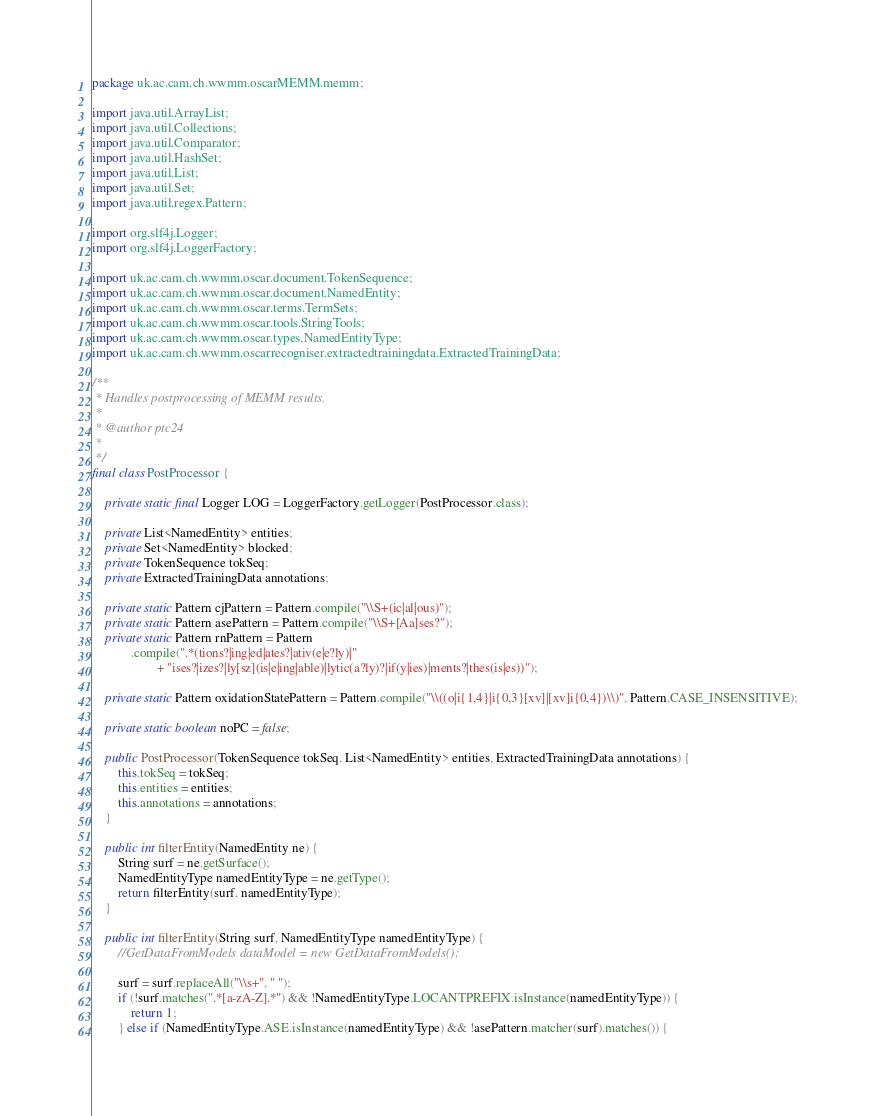<code> <loc_0><loc_0><loc_500><loc_500><_Java_>package uk.ac.cam.ch.wwmm.oscarMEMM.memm;

import java.util.ArrayList;
import java.util.Collections;
import java.util.Comparator;
import java.util.HashSet;
import java.util.List;
import java.util.Set;
import java.util.regex.Pattern;

import org.slf4j.Logger;
import org.slf4j.LoggerFactory;

import uk.ac.cam.ch.wwmm.oscar.document.TokenSequence;
import uk.ac.cam.ch.wwmm.oscar.document.NamedEntity;
import uk.ac.cam.ch.wwmm.oscar.terms.TermSets;
import uk.ac.cam.ch.wwmm.oscar.tools.StringTools;
import uk.ac.cam.ch.wwmm.oscar.types.NamedEntityType;
import uk.ac.cam.ch.wwmm.oscarrecogniser.extractedtrainingdata.ExtractedTrainingData;

/**
 * Handles postprocessing of MEMM results.
 * 
 * @author ptc24
 * 
 */
final class PostProcessor {

	private static final Logger LOG = LoggerFactory.getLogger(PostProcessor.class);
	
	private List<NamedEntity> entities;
	private Set<NamedEntity> blocked;
	private TokenSequence tokSeq;
	private ExtractedTrainingData annotations;

	private static Pattern cjPattern = Pattern.compile("\\S+(ic|al|ous)");
	private static Pattern asePattern = Pattern.compile("\\S+[Aa]ses?");
	private static Pattern rnPattern = Pattern
			.compile(".*(tions?|ing|ed|ates?|ativ(e|e?ly)|"
					+ "ises?|izes?|ly[sz](is|e|ing|able)|lytic(a?ly)?|if(y|ies)|ments?|thes(is|es))");

    private static Pattern oxidationStatePattern = Pattern.compile("\\((o|i{1,4}|i{0,3}[xv]|[xv]i{0,4})\\)", Pattern.CASE_INSENSITIVE);

	private static boolean noPC = false;

	public PostProcessor(TokenSequence tokSeq, List<NamedEntity> entities, ExtractedTrainingData annotations) {
		this.tokSeq = tokSeq;
		this.entities = entities;
		this.annotations = annotations;
	}

	public int filterEntity(NamedEntity ne) {
		String surf = ne.getSurface();
		NamedEntityType namedEntityType = ne.getType();
		return filterEntity(surf, namedEntityType);
	}

	public int filterEntity(String surf, NamedEntityType namedEntityType) {
		//GetDataFromModels dataModel = new GetDataFromModels();

		surf = surf.replaceAll("\\s+", " ");
		if (!surf.matches(".*[a-zA-Z].*") && !NamedEntityType.LOCANTPREFIX.isInstance(namedEntityType)) {
			return 1;
		} else if (NamedEntityType.ASE.isInstance(namedEntityType) && !asePattern.matcher(surf).matches()) {</code> 